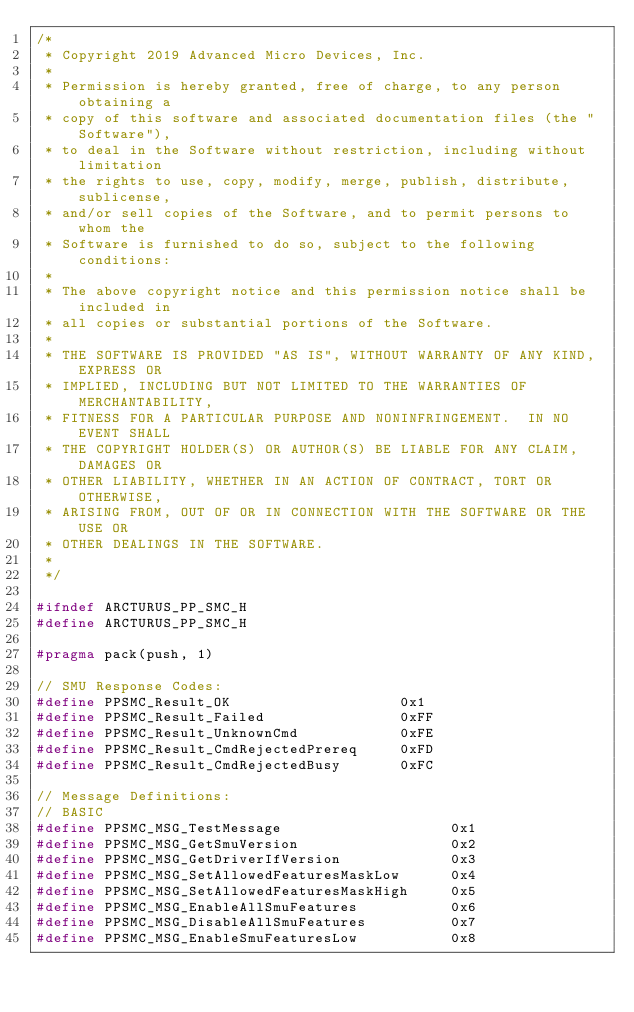<code> <loc_0><loc_0><loc_500><loc_500><_C_>/*
 * Copyright 2019 Advanced Micro Devices, Inc.
 *
 * Permission is hereby granted, free of charge, to any person obtaining a
 * copy of this software and associated documentation files (the "Software"),
 * to deal in the Software without restriction, including without limitation
 * the rights to use, copy, modify, merge, publish, distribute, sublicense,
 * and/or sell copies of the Software, and to permit persons to whom the
 * Software is furnished to do so, subject to the following conditions:
 *
 * The above copyright notice and this permission notice shall be included in
 * all copies or substantial portions of the Software.
 *
 * THE SOFTWARE IS PROVIDED "AS IS", WITHOUT WARRANTY OF ANY KIND, EXPRESS OR
 * IMPLIED, INCLUDING BUT NOT LIMITED TO THE WARRANTIES OF MERCHANTABILITY,
 * FITNESS FOR A PARTICULAR PURPOSE AND NONINFRINGEMENT.  IN NO EVENT SHALL
 * THE COPYRIGHT HOLDER(S) OR AUTHOR(S) BE LIABLE FOR ANY CLAIM, DAMAGES OR
 * OTHER LIABILITY, WHETHER IN AN ACTION OF CONTRACT, TORT OR OTHERWISE,
 * ARISING FROM, OUT OF OR IN CONNECTION WITH THE SOFTWARE OR THE USE OR
 * OTHER DEALINGS IN THE SOFTWARE.
 *
 */

#ifndef ARCTURUS_PP_SMC_H
#define ARCTURUS_PP_SMC_H

#pragma pack(push, 1)

// SMU Response Codes:
#define PPSMC_Result_OK                    0x1
#define PPSMC_Result_Failed                0xFF
#define PPSMC_Result_UnknownCmd            0xFE
#define PPSMC_Result_CmdRejectedPrereq     0xFD
#define PPSMC_Result_CmdRejectedBusy       0xFC

// Message Definitions:
// BASIC
#define PPSMC_MSG_TestMessage                    0x1
#define PPSMC_MSG_GetSmuVersion                  0x2
#define PPSMC_MSG_GetDriverIfVersion             0x3
#define PPSMC_MSG_SetAllowedFeaturesMaskLow      0x4
#define PPSMC_MSG_SetAllowedFeaturesMaskHigh     0x5
#define PPSMC_MSG_EnableAllSmuFeatures           0x6
#define PPSMC_MSG_DisableAllSmuFeatures          0x7
#define PPSMC_MSG_EnableSmuFeaturesLow           0x8</code> 